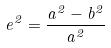<formula> <loc_0><loc_0><loc_500><loc_500>e ^ { 2 } = \frac { a ^ { 2 } - b ^ { 2 } } { a ^ { 2 } }</formula> 